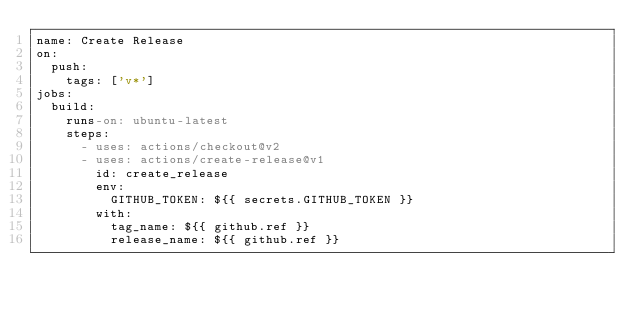<code> <loc_0><loc_0><loc_500><loc_500><_YAML_>name: Create Release
on:
  push:
    tags: ['v*']
jobs:
  build:
    runs-on: ubuntu-latest
    steps:
      - uses: actions/checkout@v2
      - uses: actions/create-release@v1
        id: create_release
        env:
          GITHUB_TOKEN: ${{ secrets.GITHUB_TOKEN }}
        with:
          tag_name: ${{ github.ref }}
          release_name: ${{ github.ref }}
</code> 